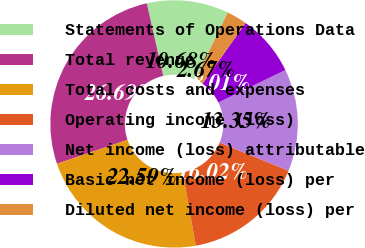Convert chart. <chart><loc_0><loc_0><loc_500><loc_500><pie_chart><fcel>Statements of Operations Data<fcel>Total revenue<fcel>Total costs and expenses<fcel>Operating income (loss)<fcel>Net income (loss) attributable<fcel>Basic net income (loss) per<fcel>Diluted net income (loss) per<nl><fcel>10.68%<fcel>26.69%<fcel>22.59%<fcel>16.02%<fcel>13.35%<fcel>8.01%<fcel>2.67%<nl></chart> 